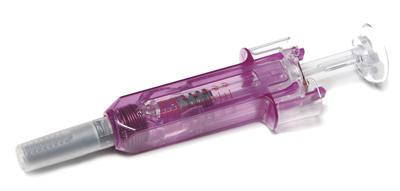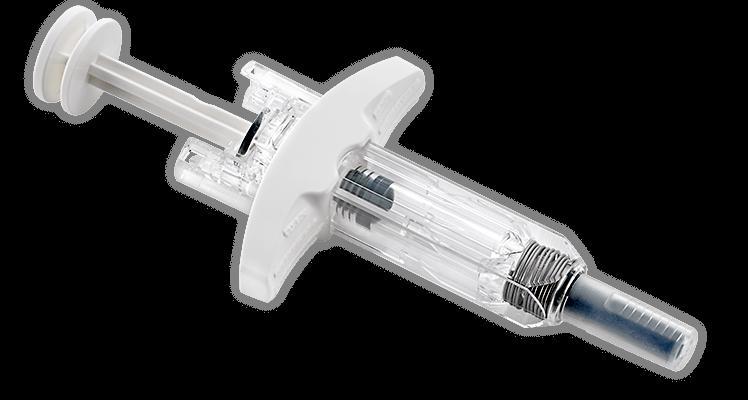The first image is the image on the left, the second image is the image on the right. Examine the images to the left and right. Is the description "A total of two syringes are shown." accurate? Answer yes or no. Yes. 